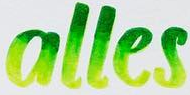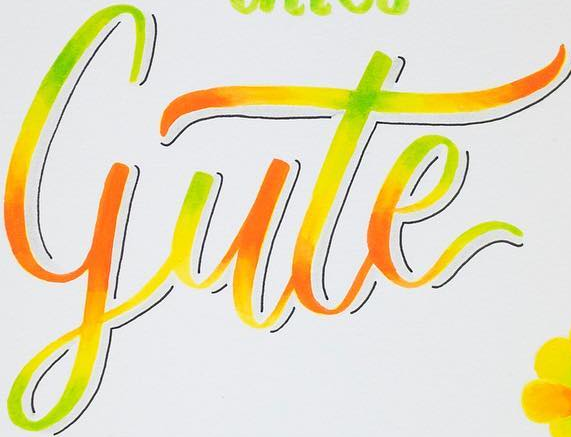Read the text content from these images in order, separated by a semicolon. alles; gute 